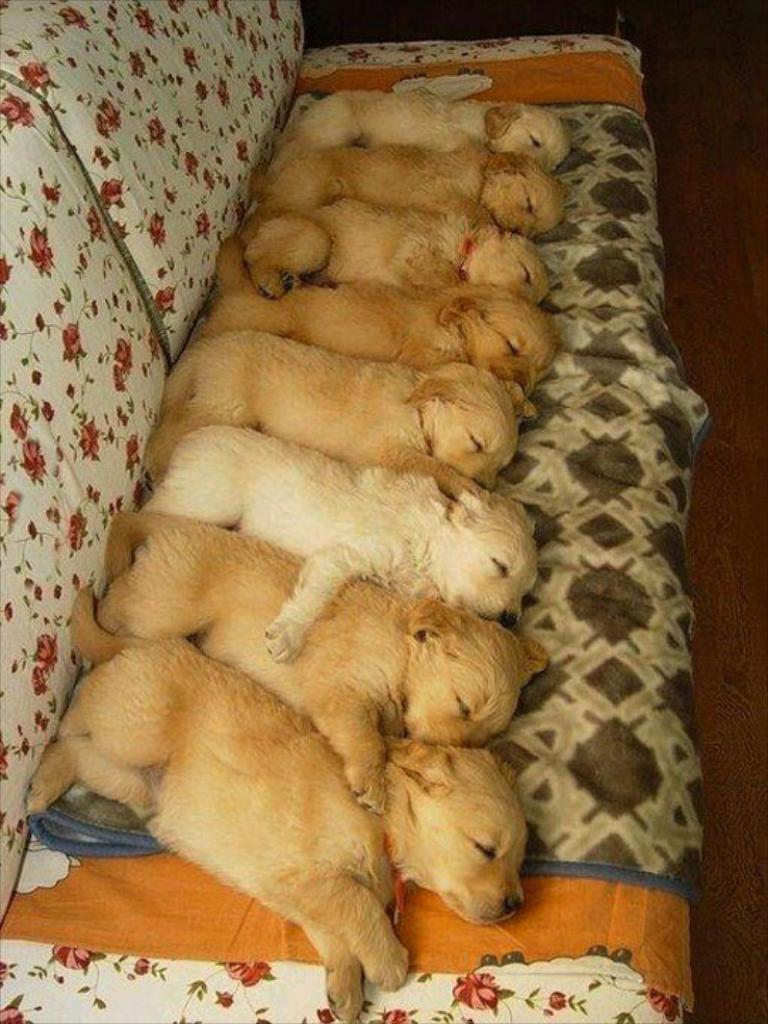What type of animals are in the image? There are puppies in the image. What are the puppies doing in the image? The puppies are sleeping. Where are the puppies located in the image? The puppies are on a sofa. What type of bells can be seen on the puppies' tails in the image? There are no bells present on the puppies' tails in the image. 